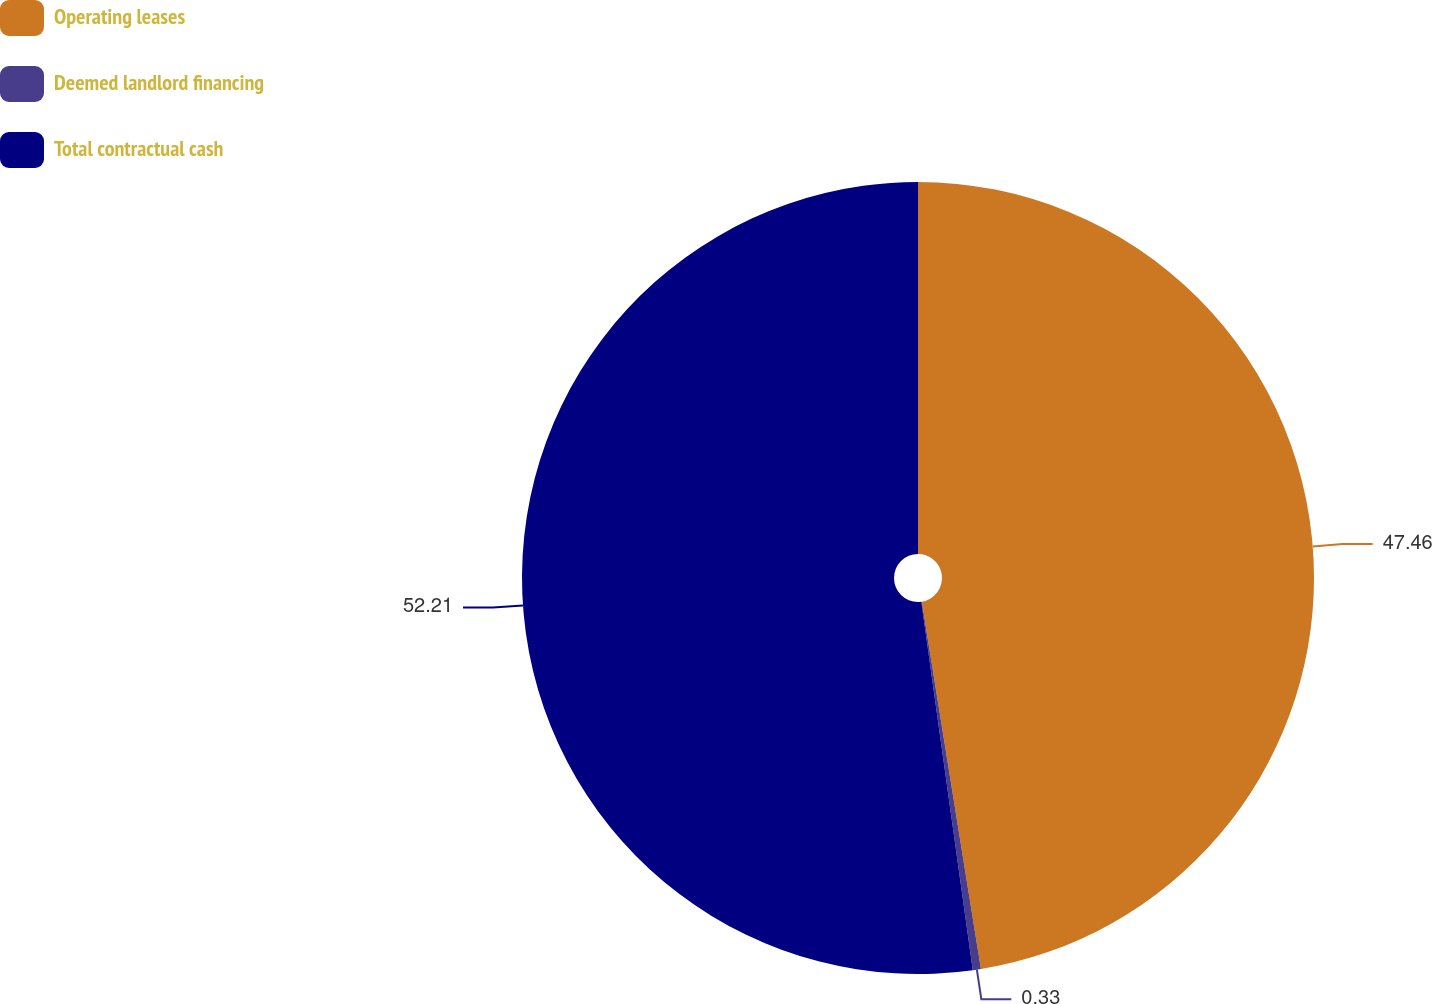Convert chart to OTSL. <chart><loc_0><loc_0><loc_500><loc_500><pie_chart><fcel>Operating leases<fcel>Deemed landlord financing<fcel>Total contractual cash<nl><fcel>47.46%<fcel>0.33%<fcel>52.21%<nl></chart> 